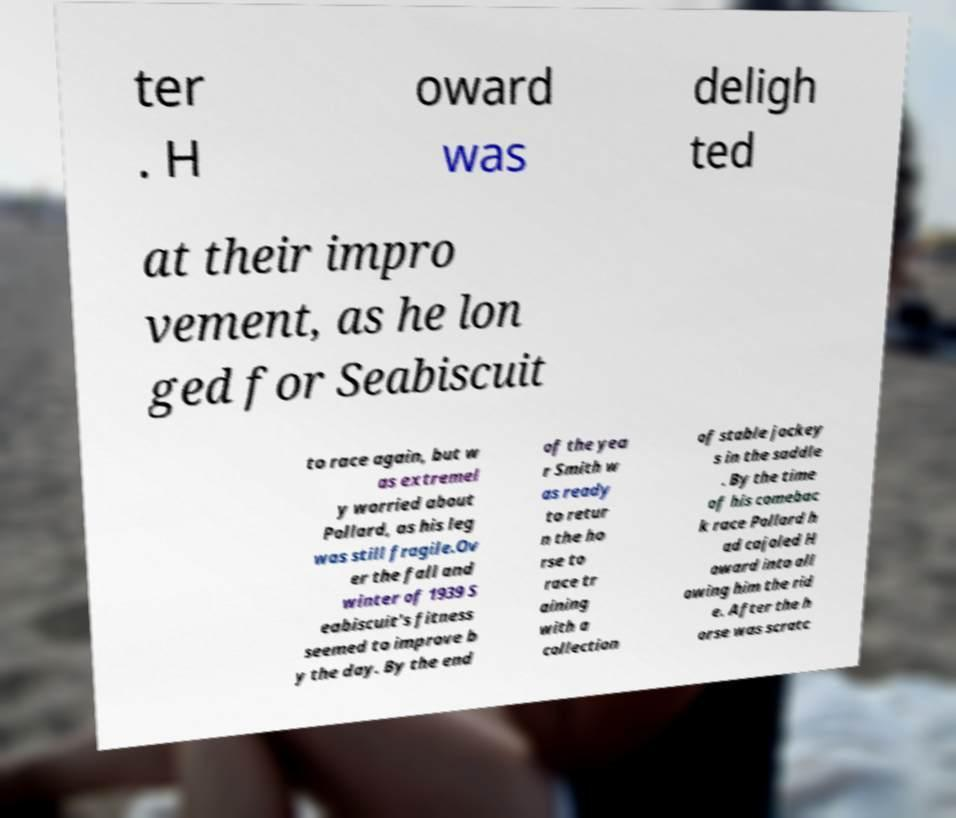Can you accurately transcribe the text from the provided image for me? ter . H oward was deligh ted at their impro vement, as he lon ged for Seabiscuit to race again, but w as extremel y worried about Pollard, as his leg was still fragile.Ov er the fall and winter of 1939 S eabiscuit's fitness seemed to improve b y the day. By the end of the yea r Smith w as ready to retur n the ho rse to race tr aining with a collection of stable jockey s in the saddle . By the time of his comebac k race Pollard h ad cajoled H oward into all owing him the rid e. After the h orse was scratc 